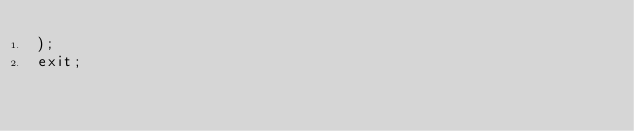<code> <loc_0><loc_0><loc_500><loc_500><_SQL_>);
exit;</code> 